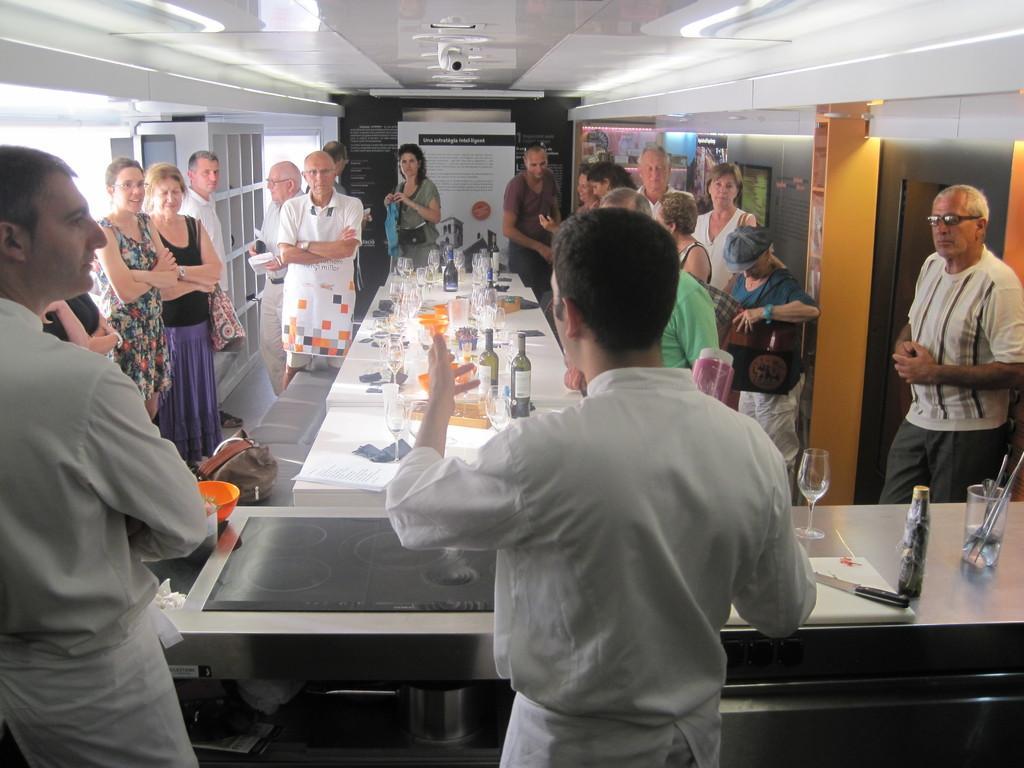Please provide a concise description of this image. In the image there is a table and on the table there are many glasses, bottles and some other items are kept, in front of the table there are two people standing beside a cooking table, they are wearing chef coats and around the table there are, many people standing and behind them many posters were attached to the wall and there is a camera fit to the roof of the room. 